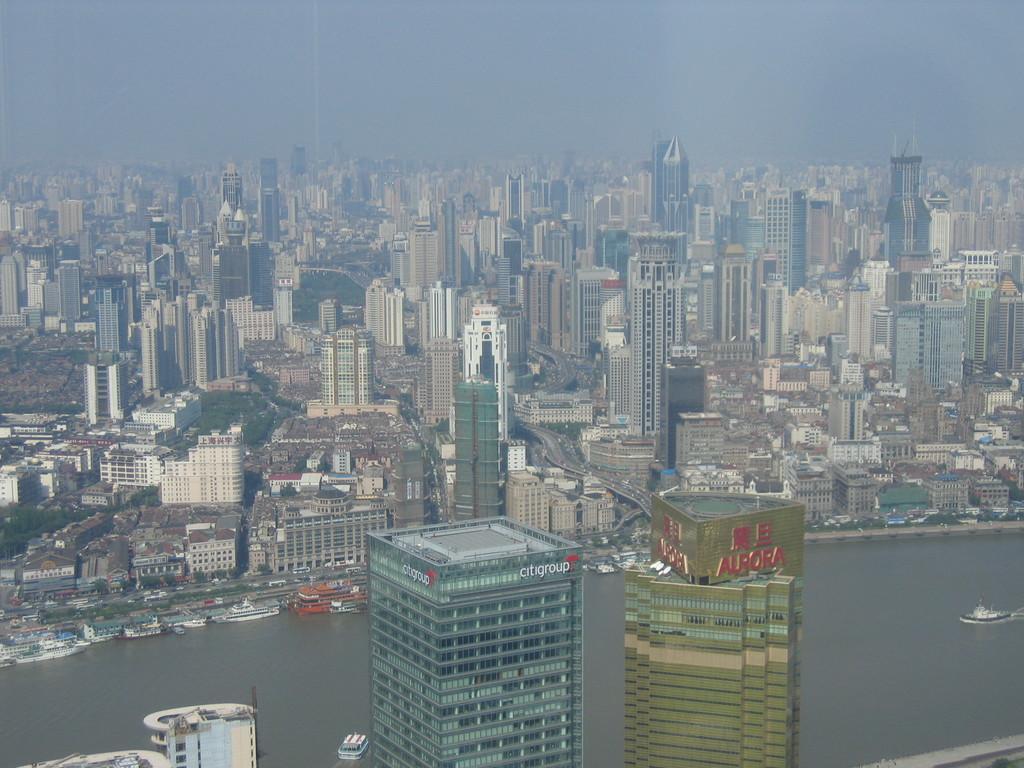Could you give a brief overview of what you see in this image? This image is taken from the top, where we can see the city which includes buildings, water, boats, few ships and the sky. 